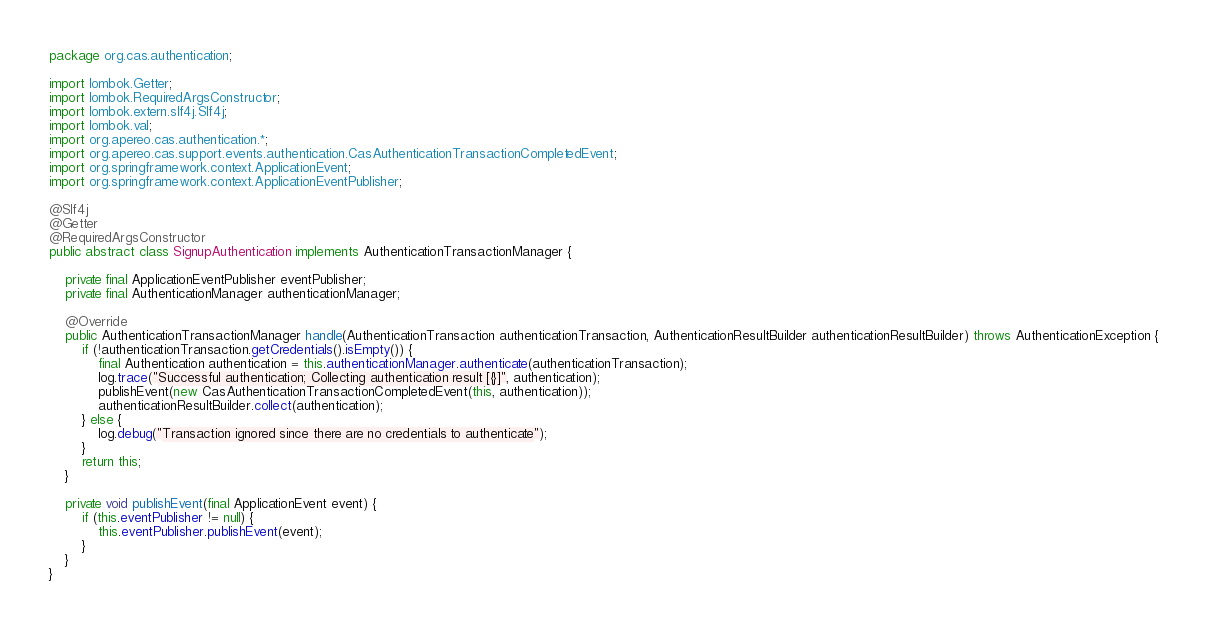Convert code to text. <code><loc_0><loc_0><loc_500><loc_500><_Java_>package org.cas.authentication;

import lombok.Getter;
import lombok.RequiredArgsConstructor;
import lombok.extern.slf4j.Slf4j;
import lombok.val;
import org.apereo.cas.authentication.*;
import org.apereo.cas.support.events.authentication.CasAuthenticationTransactionCompletedEvent;
import org.springframework.context.ApplicationEvent;
import org.springframework.context.ApplicationEventPublisher;

@Slf4j
@Getter
@RequiredArgsConstructor
public abstract class SignupAuthentication implements AuthenticationTransactionManager {

    private final ApplicationEventPublisher eventPublisher;
    private final AuthenticationManager authenticationManager;

    @Override
    public AuthenticationTransactionManager handle(AuthenticationTransaction authenticationTransaction, AuthenticationResultBuilder authenticationResultBuilder) throws AuthenticationException {
        if (!authenticationTransaction.getCredentials().isEmpty()) {
            final Authentication authentication = this.authenticationManager.authenticate(authenticationTransaction);
            log.trace("Successful authentication; Collecting authentication result [{}]", authentication);
            publishEvent(new CasAuthenticationTransactionCompletedEvent(this, authentication));
            authenticationResultBuilder.collect(authentication);
        } else {
            log.debug("Transaction ignored since there are no credentials to authenticate");
        }
        return this;
    }

    private void publishEvent(final ApplicationEvent event) {
        if (this.eventPublisher != null) {
            this.eventPublisher.publishEvent(event);
        }
    }
}
</code> 